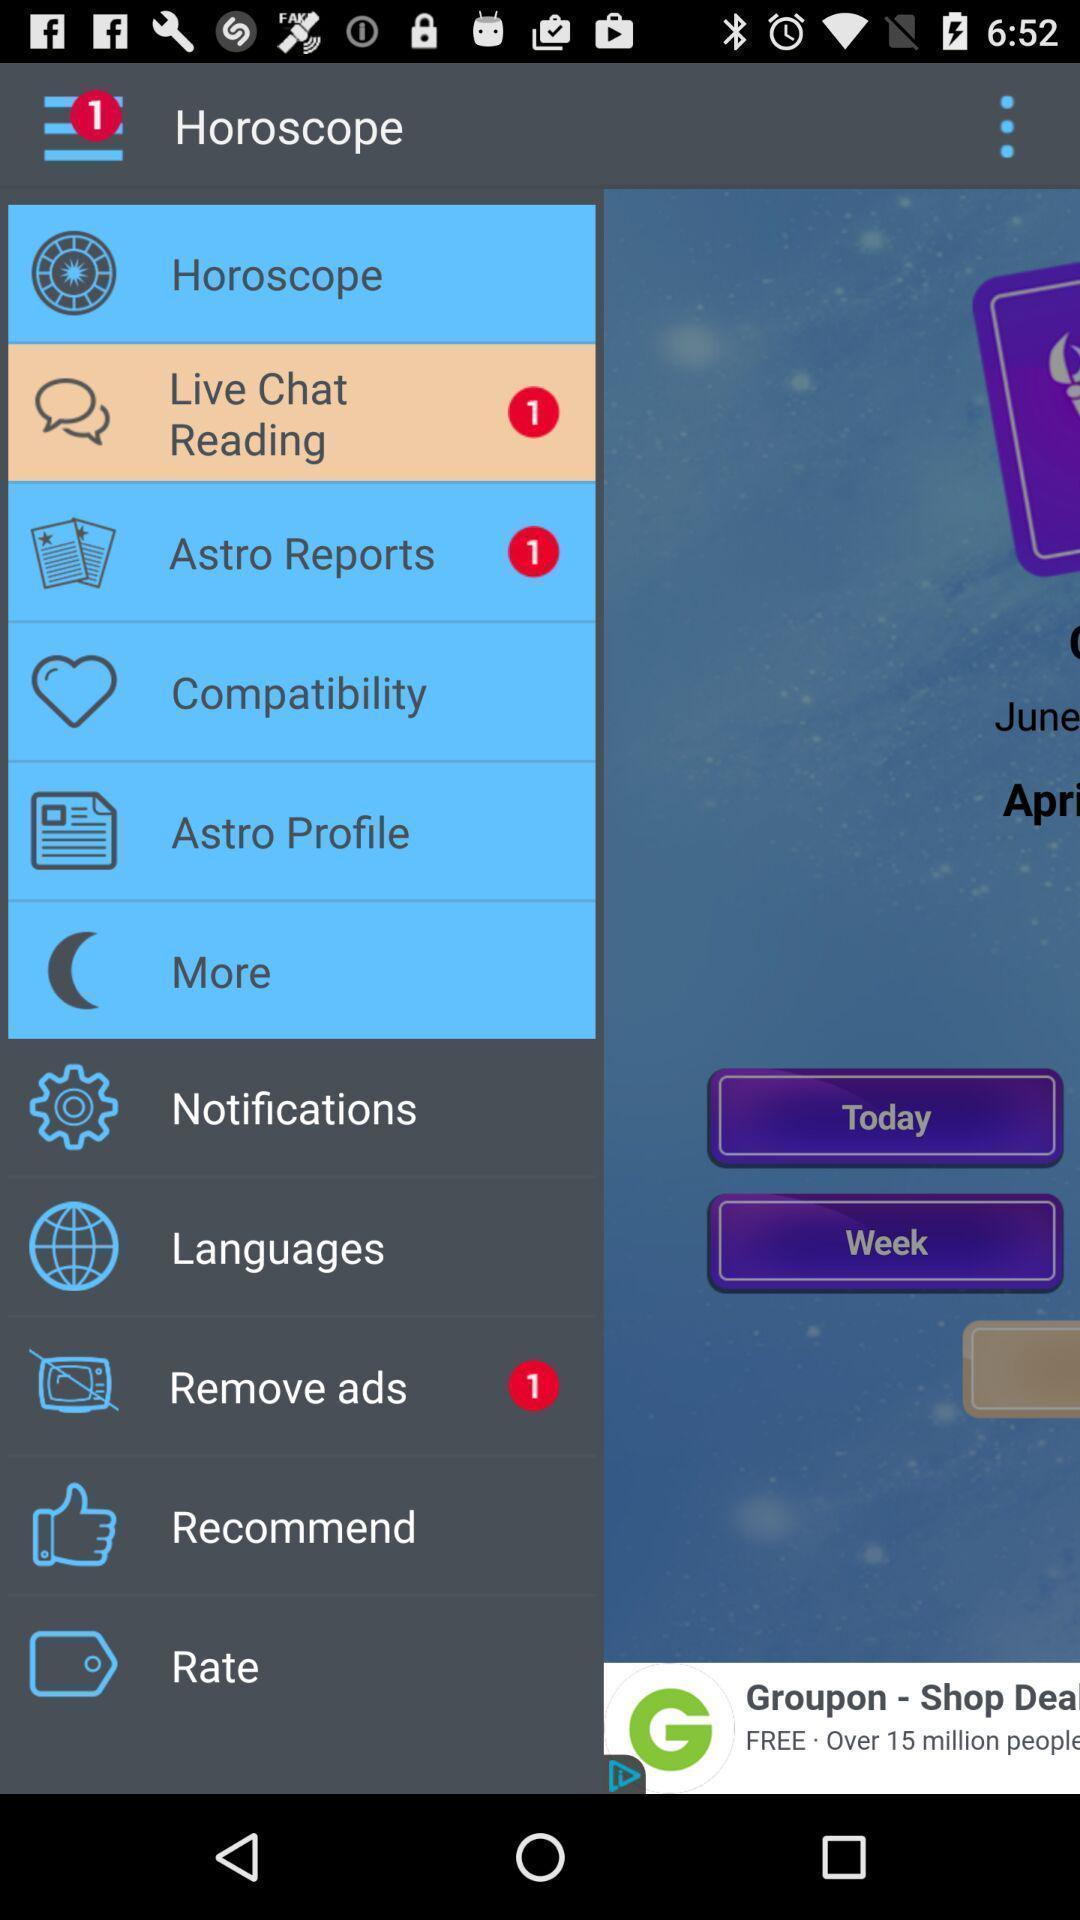Describe this image in words. Popup showing horoscope and other options. 